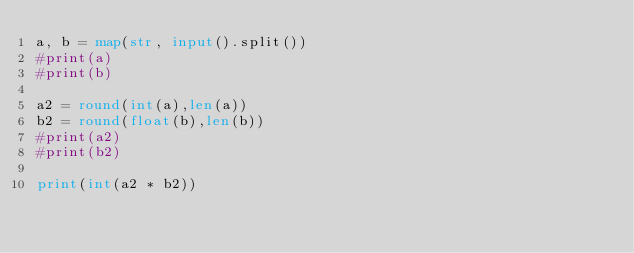Convert code to text. <code><loc_0><loc_0><loc_500><loc_500><_Python_>a, b = map(str, input().split())
#print(a)
#print(b)

a2 = round(int(a),len(a))
b2 = round(float(b),len(b))
#print(a2)
#print(b2)

print(int(a2 * b2))

</code> 